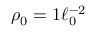Convert formula to latex. <formula><loc_0><loc_0><loc_500><loc_500>\rho _ { 0 } = 1 \ell _ { 0 } ^ { - 2 }</formula> 